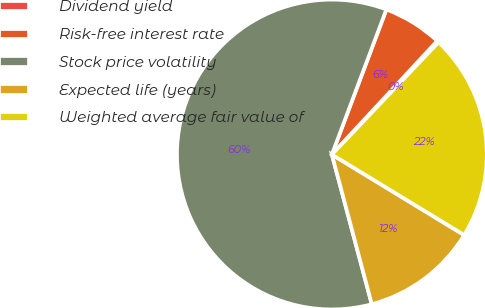Convert chart. <chart><loc_0><loc_0><loc_500><loc_500><pie_chart><fcel>Dividend yield<fcel>Risk-free interest rate<fcel>Stock price volatility<fcel>Expected life (years)<fcel>Weighted average fair value of<nl><fcel>0.19%<fcel>6.18%<fcel>59.86%<fcel>12.15%<fcel>21.61%<nl></chart> 